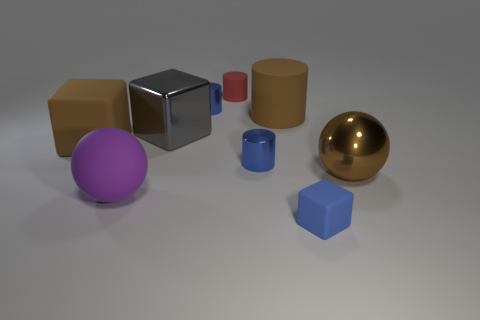Add 1 blue matte things. How many objects exist? 10 Subtract all blocks. How many objects are left? 6 Subtract 0 purple cylinders. How many objects are left? 9 Subtract all large brown metallic balls. Subtract all red rubber things. How many objects are left? 7 Add 8 brown matte objects. How many brown matte objects are left? 10 Add 4 big gray matte balls. How many big gray matte balls exist? 4 